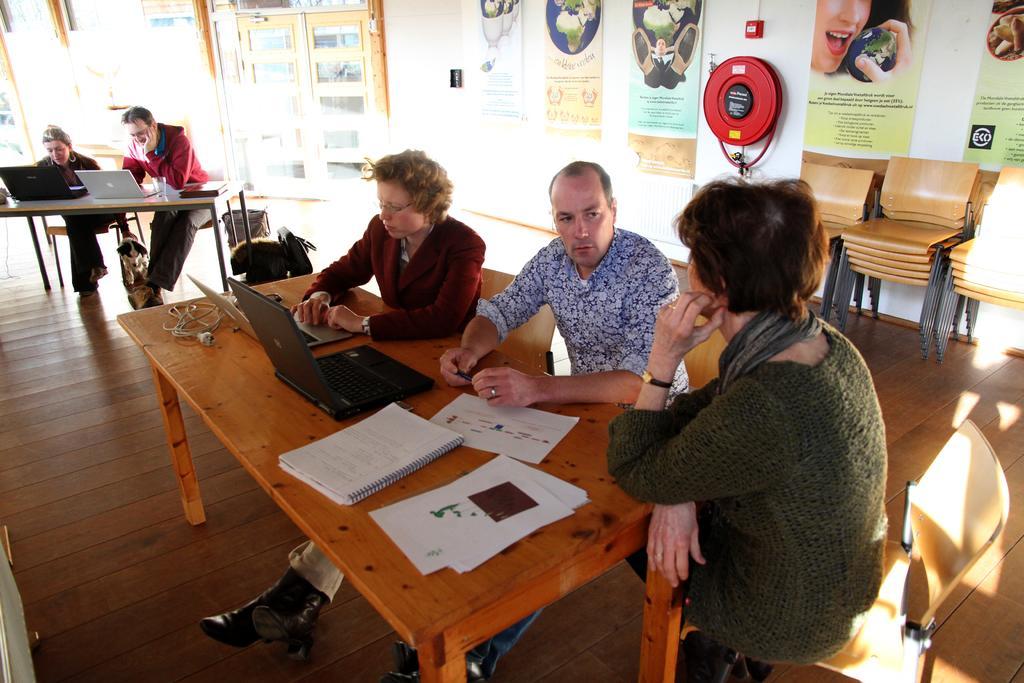Please provide a concise description of this image. There is a group of people. They are sitting on chairs. There is a table. There is a laptop,file,book on a table. We can see in background posters,wall. 